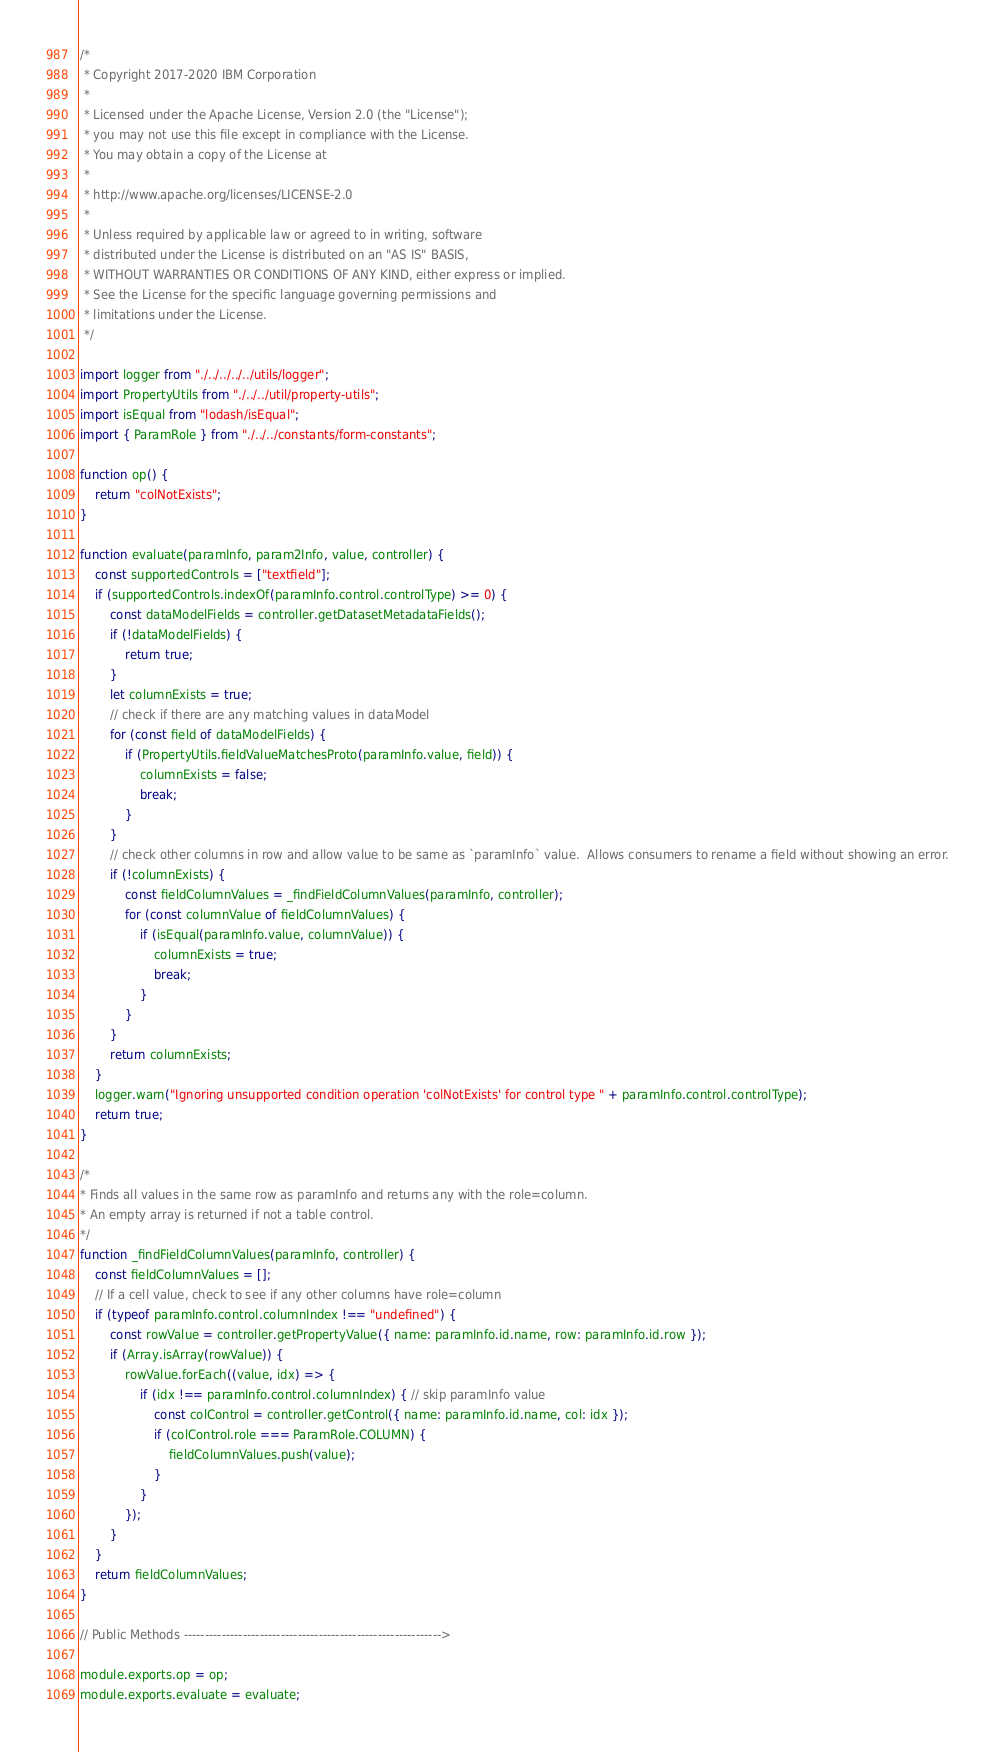Convert code to text. <code><loc_0><loc_0><loc_500><loc_500><_JavaScript_>/*
 * Copyright 2017-2020 IBM Corporation
 *
 * Licensed under the Apache License, Version 2.0 (the "License");
 * you may not use this file except in compliance with the License.
 * You may obtain a copy of the License at
 *
 * http://www.apache.org/licenses/LICENSE-2.0
 *
 * Unless required by applicable law or agreed to in writing, software
 * distributed under the License is distributed on an "AS IS" BASIS,
 * WITHOUT WARRANTIES OR CONDITIONS OF ANY KIND, either express or implied.
 * See the License for the specific language governing permissions and
 * limitations under the License.
 */

import logger from "./../../../../utils/logger";
import PropertyUtils from "./../../util/property-utils";
import isEqual from "lodash/isEqual";
import { ParamRole } from "./../../constants/form-constants";

function op() {
	return "colNotExists";
}

function evaluate(paramInfo, param2Info, value, controller) {
	const supportedControls = ["textfield"];
	if (supportedControls.indexOf(paramInfo.control.controlType) >= 0) {
		const dataModelFields = controller.getDatasetMetadataFields();
		if (!dataModelFields) {
			return true;
		}
		let columnExists = true;
		// check if there are any matching values in dataModel
		for (const field of dataModelFields) {
			if (PropertyUtils.fieldValueMatchesProto(paramInfo.value, field)) {
				columnExists = false;
				break;
			}
		}
		// check other columns in row and allow value to be same as `paramInfo` value.  Allows consumers to rename a field without showing an error.
		if (!columnExists) {
			const fieldColumnValues = _findFieldColumnValues(paramInfo, controller);
			for (const columnValue of fieldColumnValues) {
				if (isEqual(paramInfo.value, columnValue)) {
					columnExists = true;
					break;
				}
			}
		}
		return columnExists;
	}
	logger.warn("Ignoring unsupported condition operation 'colNotExists' for control type " + paramInfo.control.controlType);
	return true;
}

/*
* Finds all values in the same row as paramInfo and returns any with the role=column.
* An empty array is returned if not a table control.
*/
function _findFieldColumnValues(paramInfo, controller) {
	const fieldColumnValues = [];
	// If a cell value, check to see if any other columns have role=column
	if (typeof paramInfo.control.columnIndex !== "undefined") {
		const rowValue = controller.getPropertyValue({ name: paramInfo.id.name, row: paramInfo.id.row });
		if (Array.isArray(rowValue)) {
			rowValue.forEach((value, idx) => {
				if (idx !== paramInfo.control.columnIndex) { // skip paramInfo value
					const colControl = controller.getControl({ name: paramInfo.id.name, col: idx });
					if (colControl.role === ParamRole.COLUMN) {
						fieldColumnValues.push(value);
					}
				}
			});
		}
	}
	return fieldColumnValues;
}

// Public Methods ------------------------------------------------------------->

module.exports.op = op;
module.exports.evaluate = evaluate;
</code> 